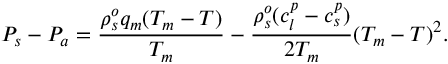<formula> <loc_0><loc_0><loc_500><loc_500>P _ { s } - P _ { a } = \frac { \rho _ { s } ^ { o } q _ { m } ( T _ { m } - T ) } { T _ { m } } - \frac { \rho _ { s } ^ { o } ( c _ { l } ^ { p } - c _ { s } ^ { p } ) } { 2 T _ { m } } ( T _ { m } - T ) ^ { 2 } .</formula> 